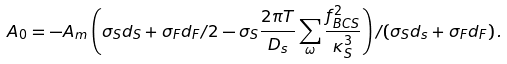Convert formula to latex. <formula><loc_0><loc_0><loc_500><loc_500>A _ { 0 } = - A _ { m } \left ( \sigma _ { S } d _ { S } + \sigma _ { F } d _ { F } / 2 - \sigma _ { S } \frac { 2 \pi T } { D _ { s } } \sum _ { \omega } \frac { f _ { B C S } ^ { 2 } } { \kappa _ { S } ^ { 3 } } \right ) / ( \sigma _ { S } d _ { s } + \sigma _ { F } d _ { F } ) \, .</formula> 